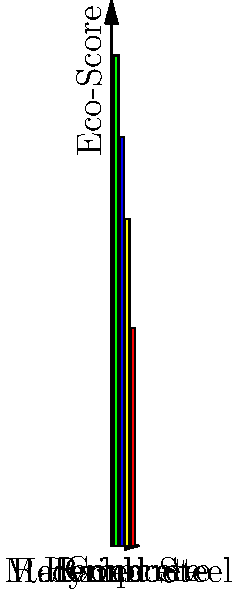Based on the eco-score chart of building materials shown above, which material would be most suitable for your affordable housing project to minimize environmental impact? To determine the most suitable material for an affordable housing project with minimal environmental impact, we need to analyze the eco-scores presented in the chart:

1. Identify the materials: The chart shows four materials - Bamboo, Recycled Steel, Hempcrete, and Concrete.

2. Compare eco-scores:
   - Bamboo: 90
   - Recycled Steel: 75
   - Hempcrete: 60
   - Concrete: 40

3. Interpret the scores: A higher eco-score indicates a more environmentally friendly material.

4. Rank the materials: 
   1. Bamboo (90)
   2. Recycled Steel (75)
   3. Hempcrete (60)
   4. Concrete (40)

5. Consider the project requirements:
   - As a nonprofit director, affordability is crucial.
   - The goal is to minimize environmental impact.

6. Make a decision: Bamboo has the highest eco-score (90), indicating it has the least environmental impact among the options presented.

Therefore, based solely on the eco-score and the goal of minimizing environmental impact, bamboo would be the most suitable material for the affordable housing project.
Answer: Bamboo 